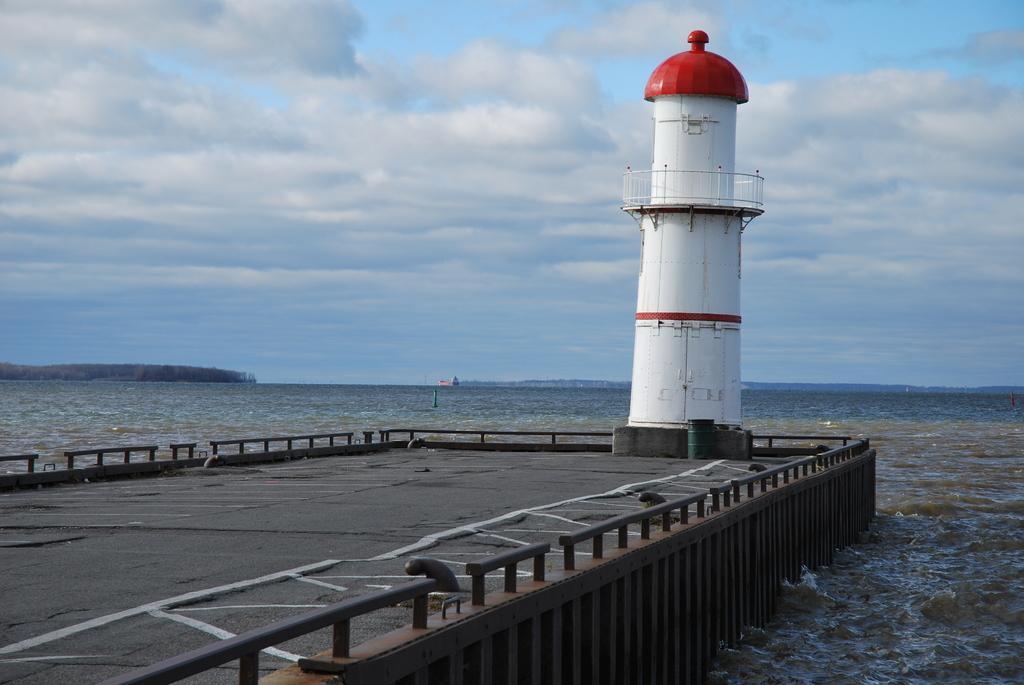Could you give a brief overview of what you see in this image? In this image I can see white colour light house. In background I can see water clouds and the sky. 